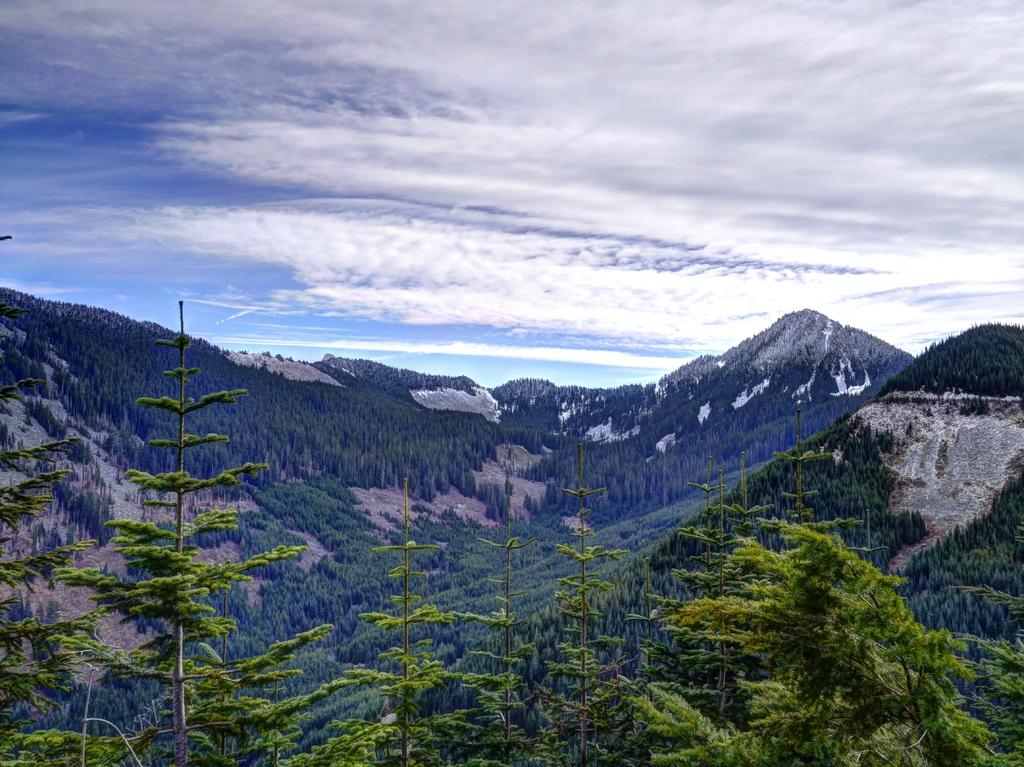What type of landscape is shown in the image? The image depicts a mountain. What natural features can be seen in the image? There are many trees in the image. What is the condition of the sky in the image? The sky in the image is cloudy. What type of basin is visible at the base of the mountain in the image? There is no basin visible at the base of the mountain in the image. Can you see a plane flying over the mountain in the image? There is no plane visible in the image. 